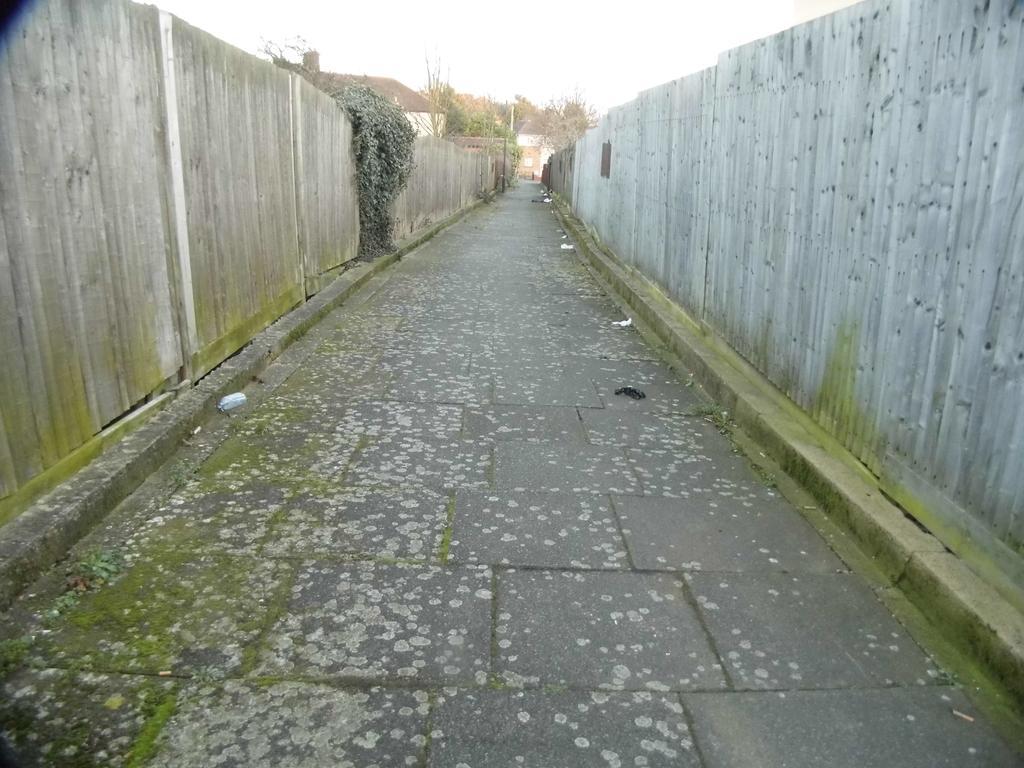Please provide a concise description of this image. In the middle of the picture, we see the road. On either side of the picture, we see walls, which are made up of corrugated iron sheets. On the left side, we see a tree. There are trees and a building in the background. At the top, we see the sky. 